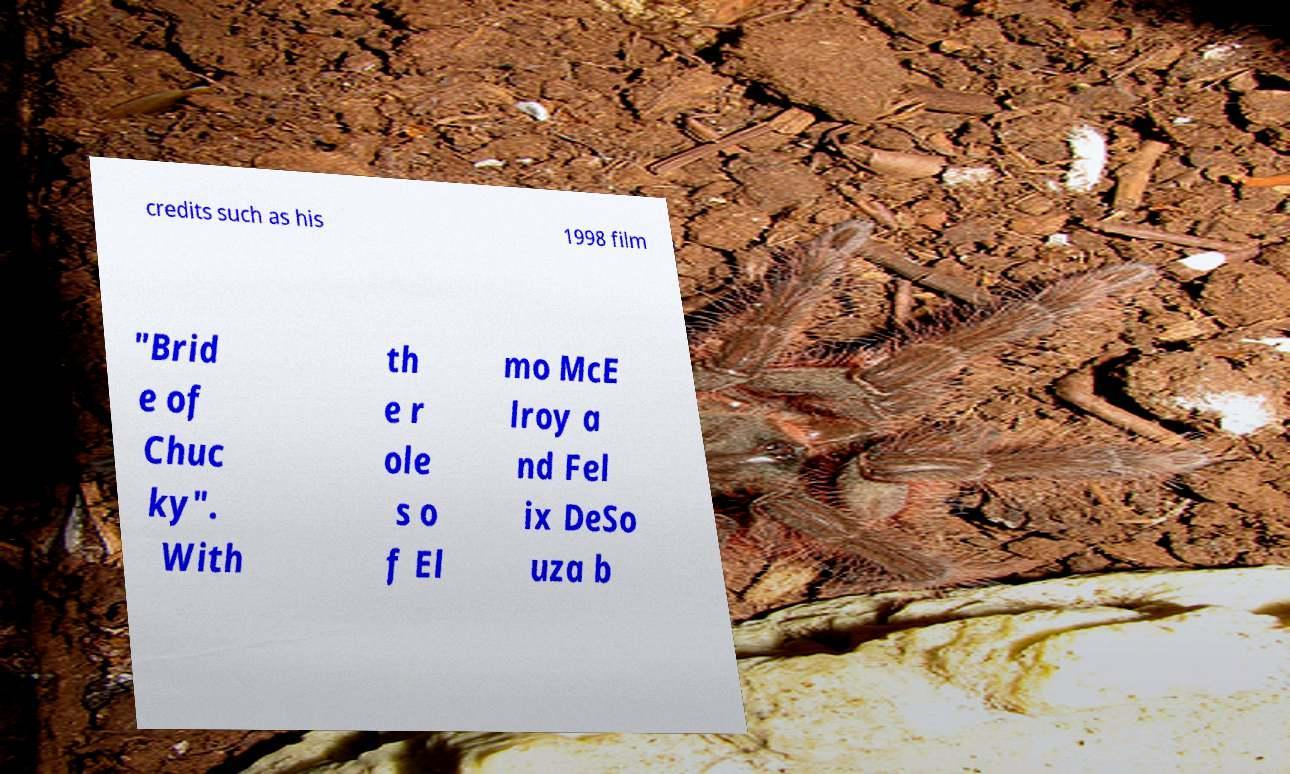I need the written content from this picture converted into text. Can you do that? credits such as his 1998 film "Brid e of Chuc ky". With th e r ole s o f El mo McE lroy a nd Fel ix DeSo uza b 